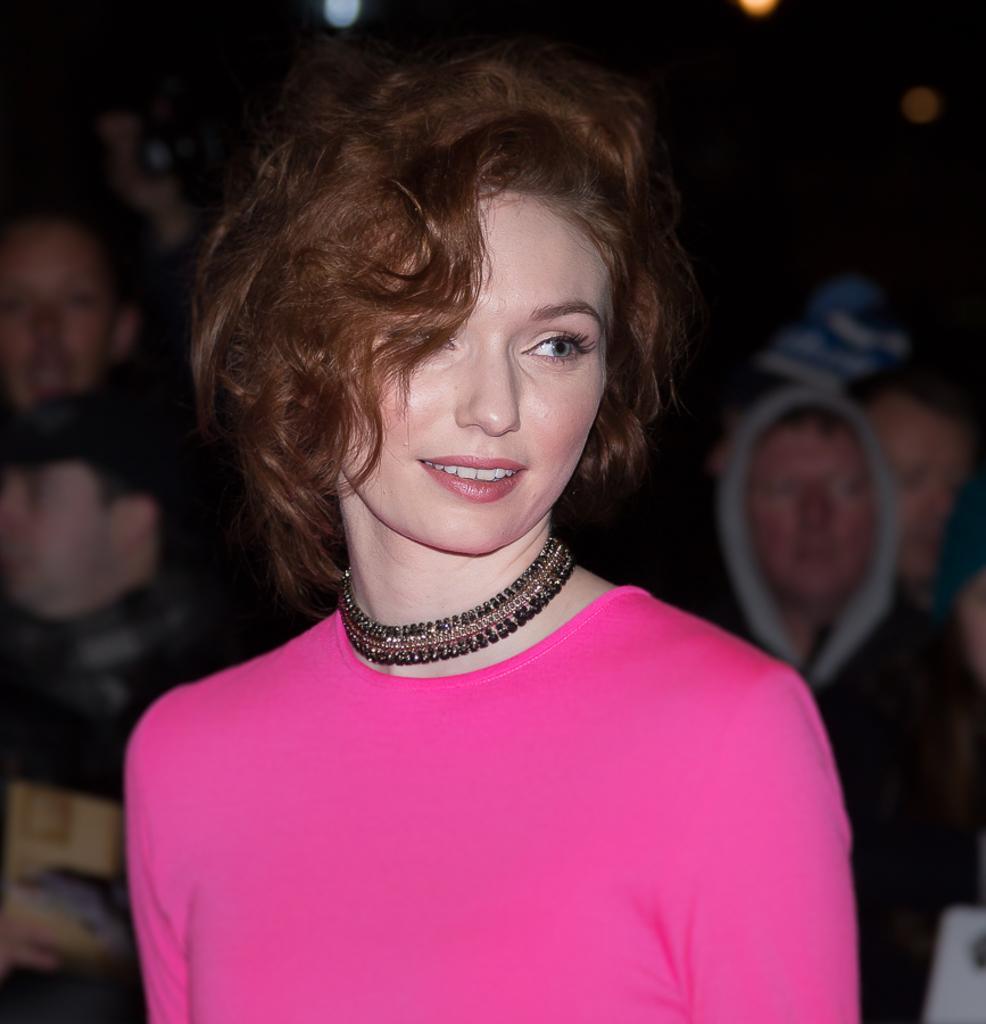Can you describe this image briefly? In this image I can see a woman wearing pink dress and black colored necklace. In the background I can see few other persons. 